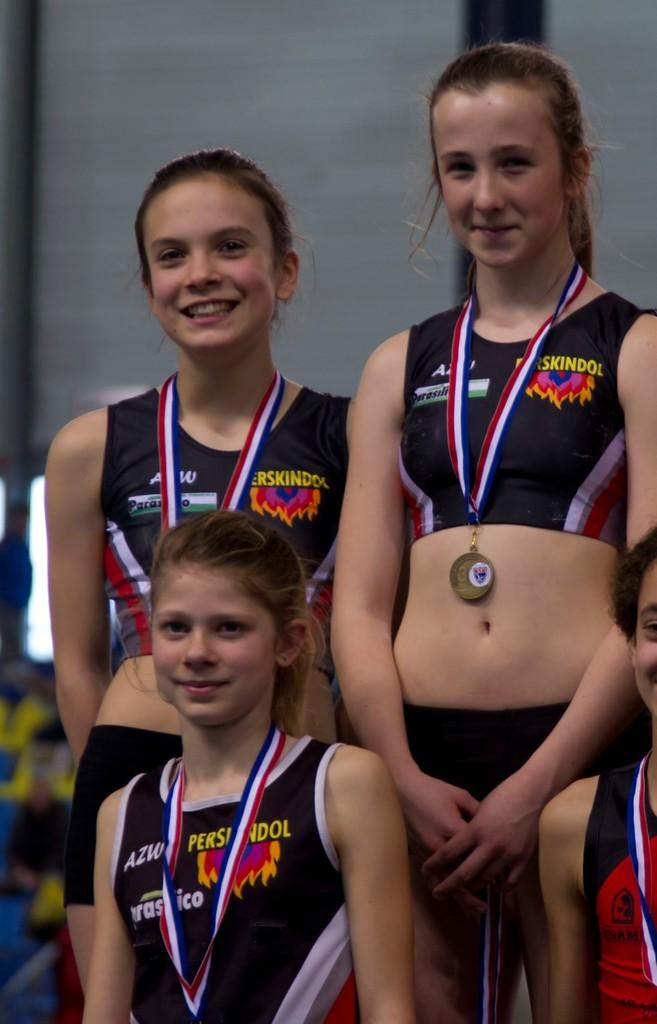Provide a one-sentence caption for the provided image. Three girls are wearing medals and their shirts say perskindol. 